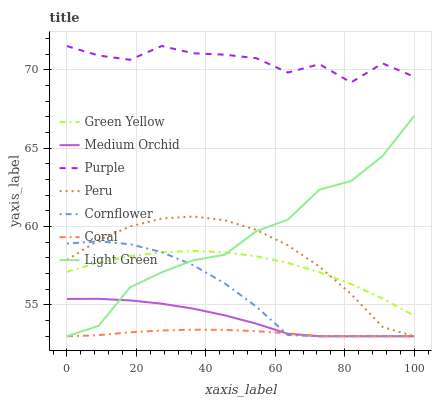Does Coral have the minimum area under the curve?
Answer yes or no. Yes. Does Purple have the maximum area under the curve?
Answer yes or no. Yes. Does Light Green have the minimum area under the curve?
Answer yes or no. No. Does Light Green have the maximum area under the curve?
Answer yes or no. No. Is Coral the smoothest?
Answer yes or no. Yes. Is Purple the roughest?
Answer yes or no. Yes. Is Light Green the smoothest?
Answer yes or no. No. Is Light Green the roughest?
Answer yes or no. No. Does Purple have the lowest value?
Answer yes or no. No. Does Purple have the highest value?
Answer yes or no. Yes. Does Light Green have the highest value?
Answer yes or no. No. Is Coral less than Purple?
Answer yes or no. Yes. Is Purple greater than Peru?
Answer yes or no. Yes. Does Medium Orchid intersect Light Green?
Answer yes or no. Yes. Is Medium Orchid less than Light Green?
Answer yes or no. No. Is Medium Orchid greater than Light Green?
Answer yes or no. No. Does Coral intersect Purple?
Answer yes or no. No. 